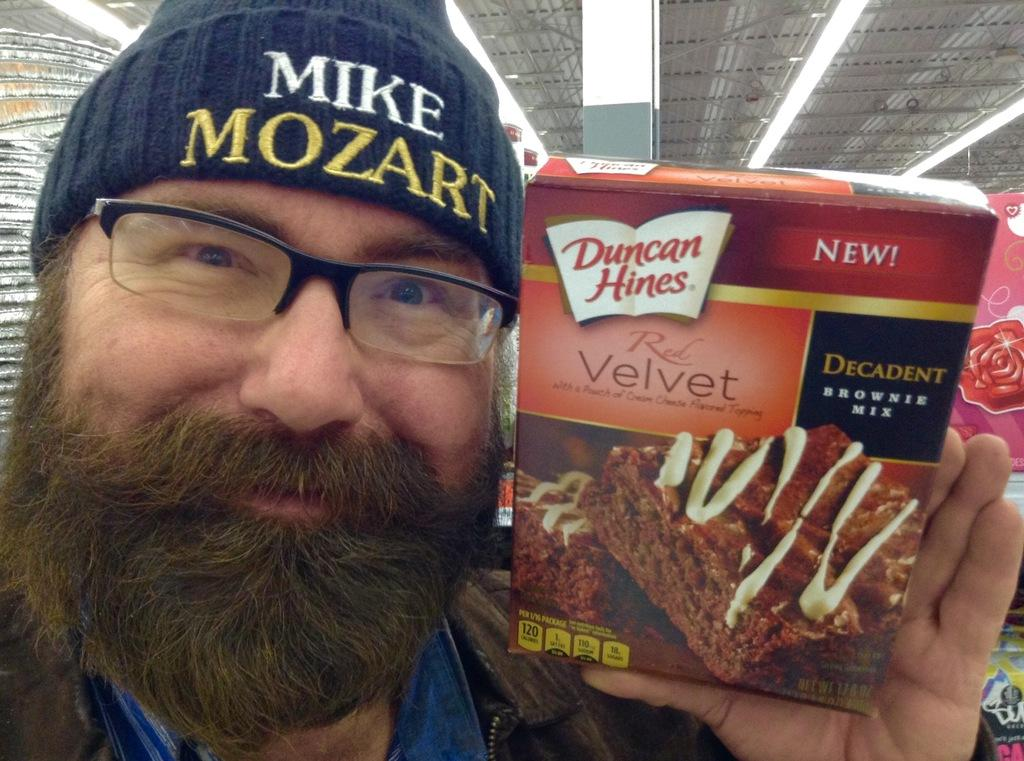What is the main subject of the picture? The main subject of the picture is a man. Can you describe the man's appearance? The man has a beard on his face. Where is the man positioned in the image? The man is standing in the front. What expression does the man have? The man is smiling. What is the man holding in his hand? The man is holding a cake box in his hand. What type of structure can be seen in the background of the picture? There is an iron shed in the picture. What can be seen in the picture that provides illumination? There are lights visible in the picture. What type of test is the man conducting in the picture? There is no indication in the image that the man is conducting a test, as he is holding a cake box and smiling. What type of alarm is visible in the picture? There is no alarm present in the image; it features a man holding a cake box, standing in front of an iron shed with lights visible. 